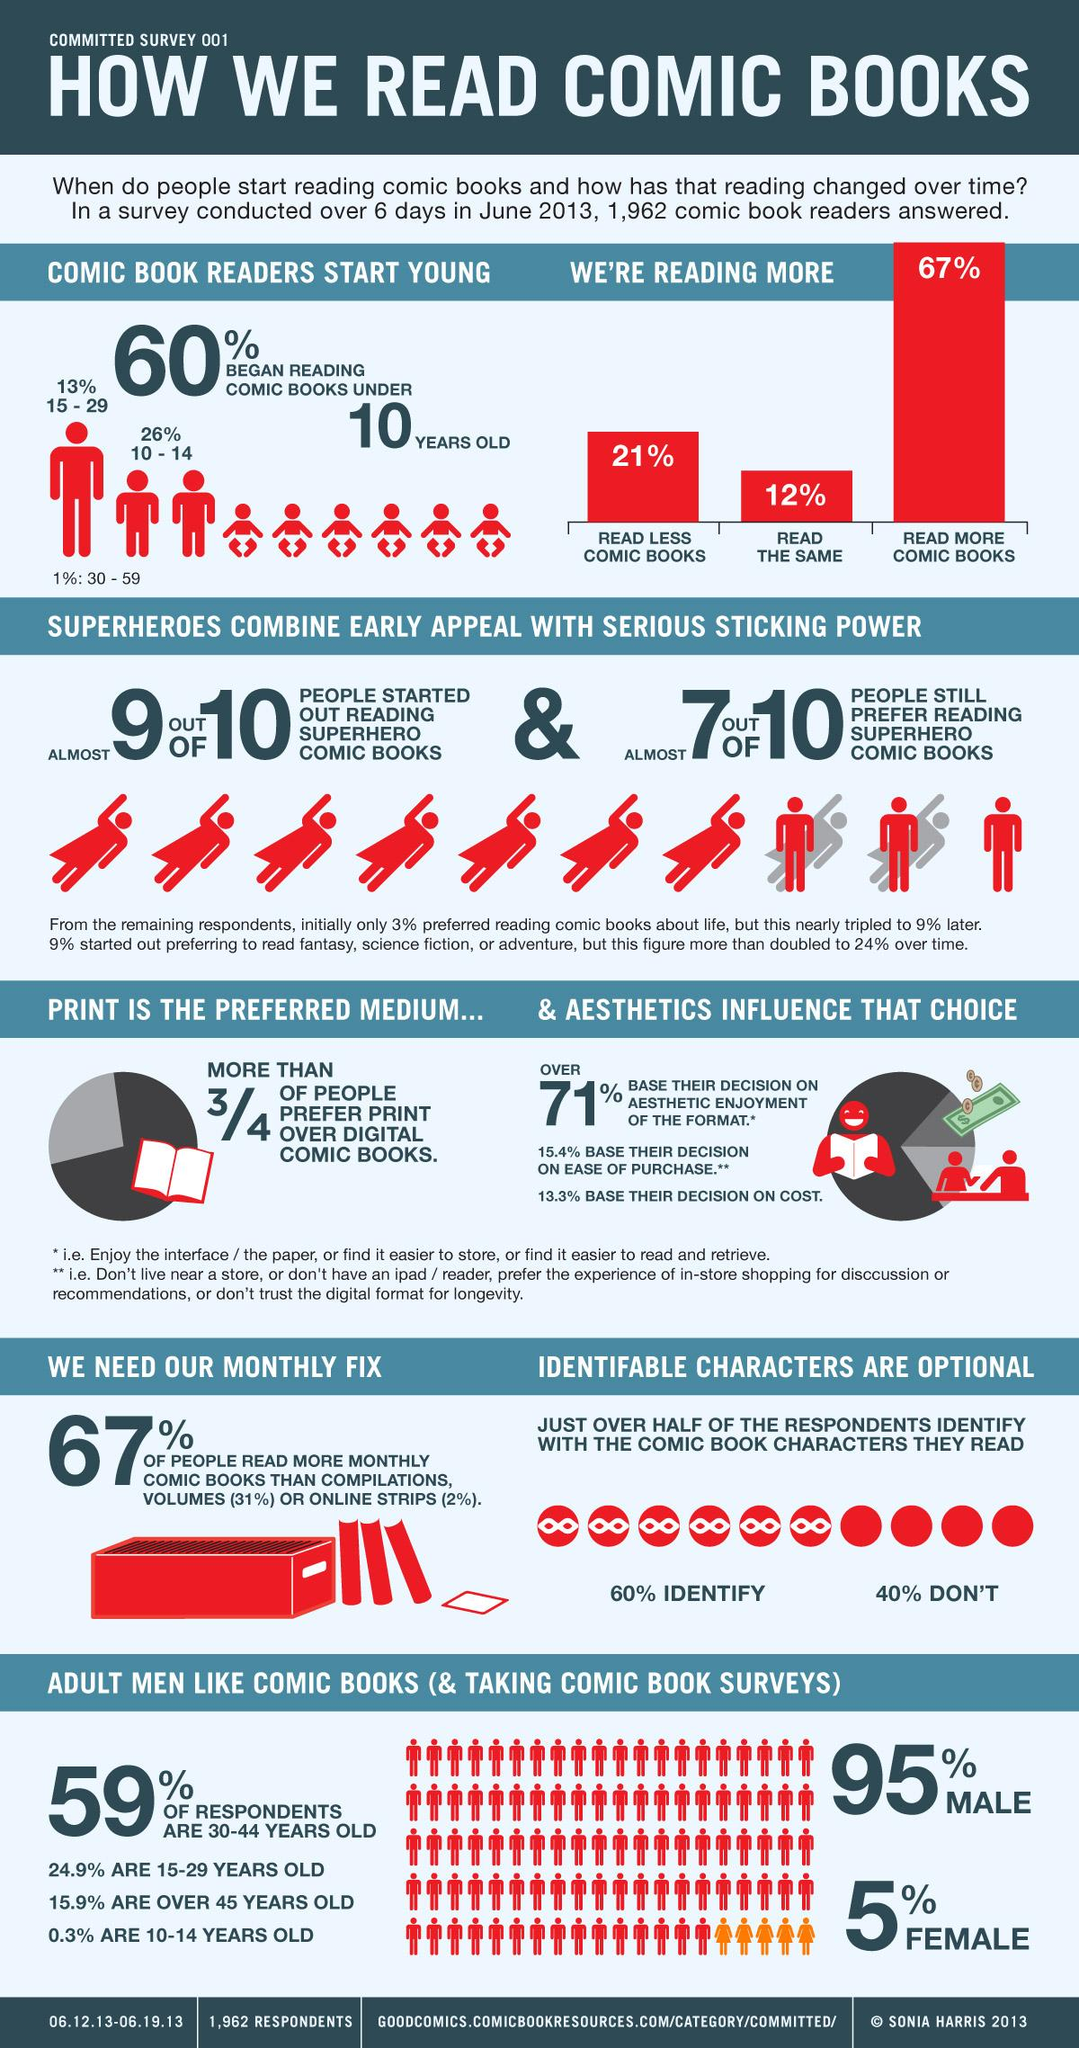Outline some significant characteristics in this image. According to a survey conducted in June 2013, 5% of women reported liking reading comic books. According to a survey conducted in June 2013, 95% of men reported liking reading comic books. According to a survey conducted in June 2013, 67% of comic book readers read more comic books. A survey conducted in June 2013 found that 40% of the respondents do not identify with the comic book characters they read. According to a survey conducted in June 2013, 21% of comic book readers read fewer comic books. 